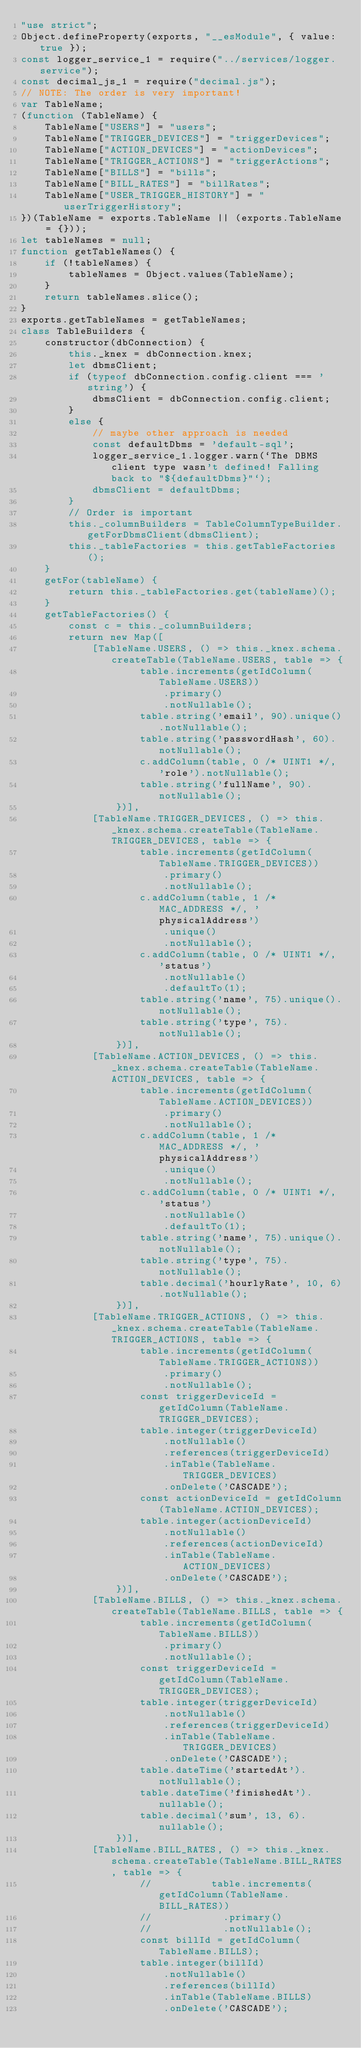Convert code to text. <code><loc_0><loc_0><loc_500><loc_500><_JavaScript_>"use strict";
Object.defineProperty(exports, "__esModule", { value: true });
const logger_service_1 = require("../services/logger.service");
const decimal_js_1 = require("decimal.js");
// NOTE: The order is very important!
var TableName;
(function (TableName) {
    TableName["USERS"] = "users";
    TableName["TRIGGER_DEVICES"] = "triggerDevices";
    TableName["ACTION_DEVICES"] = "actionDevices";
    TableName["TRIGGER_ACTIONS"] = "triggerActions";
    TableName["BILLS"] = "bills";
    TableName["BILL_RATES"] = "billRates";
    TableName["USER_TRIGGER_HISTORY"] = "userTriggerHistory";
})(TableName = exports.TableName || (exports.TableName = {}));
let tableNames = null;
function getTableNames() {
    if (!tableNames) {
        tableNames = Object.values(TableName);
    }
    return tableNames.slice();
}
exports.getTableNames = getTableNames;
class TableBuilders {
    constructor(dbConnection) {
        this._knex = dbConnection.knex;
        let dbmsClient;
        if (typeof dbConnection.config.client === 'string') {
            dbmsClient = dbConnection.config.client;
        }
        else {
            // maybe other approach is needed
            const defaultDbms = 'default-sql';
            logger_service_1.logger.warn(`The DBMS client type wasn't defined! Falling back to "${defaultDbms}"`);
            dbmsClient = defaultDbms;
        }
        // Order is important
        this._columnBuilders = TableColumnTypeBuilder.getForDbmsClient(dbmsClient);
        this._tableFactories = this.getTableFactories();
    }
    getFor(tableName) {
        return this._tableFactories.get(tableName)();
    }
    getTableFactories() {
        const c = this._columnBuilders;
        return new Map([
            [TableName.USERS, () => this._knex.schema.createTable(TableName.USERS, table => {
                    table.increments(getIdColumn(TableName.USERS))
                        .primary()
                        .notNullable();
                    table.string('email', 90).unique().notNullable();
                    table.string('passwordHash', 60).notNullable();
                    c.addColumn(table, 0 /* UINT1 */, 'role').notNullable();
                    table.string('fullName', 90).notNullable();
                })],
            [TableName.TRIGGER_DEVICES, () => this._knex.schema.createTable(TableName.TRIGGER_DEVICES, table => {
                    table.increments(getIdColumn(TableName.TRIGGER_DEVICES))
                        .primary()
                        .notNullable();
                    c.addColumn(table, 1 /* MAC_ADDRESS */, 'physicalAddress')
                        .unique()
                        .notNullable();
                    c.addColumn(table, 0 /* UINT1 */, 'status')
                        .notNullable()
                        .defaultTo(1);
                    table.string('name', 75).unique().notNullable();
                    table.string('type', 75).notNullable();
                })],
            [TableName.ACTION_DEVICES, () => this._knex.schema.createTable(TableName.ACTION_DEVICES, table => {
                    table.increments(getIdColumn(TableName.ACTION_DEVICES))
                        .primary()
                        .notNullable();
                    c.addColumn(table, 1 /* MAC_ADDRESS */, 'physicalAddress')
                        .unique()
                        .notNullable();
                    c.addColumn(table, 0 /* UINT1 */, 'status')
                        .notNullable()
                        .defaultTo(1);
                    table.string('name', 75).unique().notNullable();
                    table.string('type', 75).notNullable();
                    table.decimal('hourlyRate', 10, 6).notNullable();
                })],
            [TableName.TRIGGER_ACTIONS, () => this._knex.schema.createTable(TableName.TRIGGER_ACTIONS, table => {
                    table.increments(getIdColumn(TableName.TRIGGER_ACTIONS))
                        .primary()
                        .notNullable();
                    const triggerDeviceId = getIdColumn(TableName.TRIGGER_DEVICES);
                    table.integer(triggerDeviceId)
                        .notNullable()
                        .references(triggerDeviceId)
                        .inTable(TableName.TRIGGER_DEVICES)
                        .onDelete('CASCADE');
                    const actionDeviceId = getIdColumn(TableName.ACTION_DEVICES);
                    table.integer(actionDeviceId)
                        .notNullable()
                        .references(actionDeviceId)
                        .inTable(TableName.ACTION_DEVICES)
                        .onDelete('CASCADE');
                })],
            [TableName.BILLS, () => this._knex.schema.createTable(TableName.BILLS, table => {
                    table.increments(getIdColumn(TableName.BILLS))
                        .primary()
                        .notNullable();
                    const triggerDeviceId = getIdColumn(TableName.TRIGGER_DEVICES);
                    table.integer(triggerDeviceId)
                        .notNullable()
                        .references(triggerDeviceId)
                        .inTable(TableName.TRIGGER_DEVICES)
                        .onDelete('CASCADE');
                    table.dateTime('startedAt').notNullable();
                    table.dateTime('finishedAt').nullable();
                    table.decimal('sum', 13, 6).nullable();
                })],
            [TableName.BILL_RATES, () => this._knex.schema.createTable(TableName.BILL_RATES, table => {
                    //          table.increments(getIdColumn(TableName.BILL_RATES))
                    //            .primary()
                    //            .notNullable();
                    const billId = getIdColumn(TableName.BILLS);
                    table.integer(billId)
                        .notNullable()
                        .references(billId)
                        .inTable(TableName.BILLS)
                        .onDelete('CASCADE');</code> 